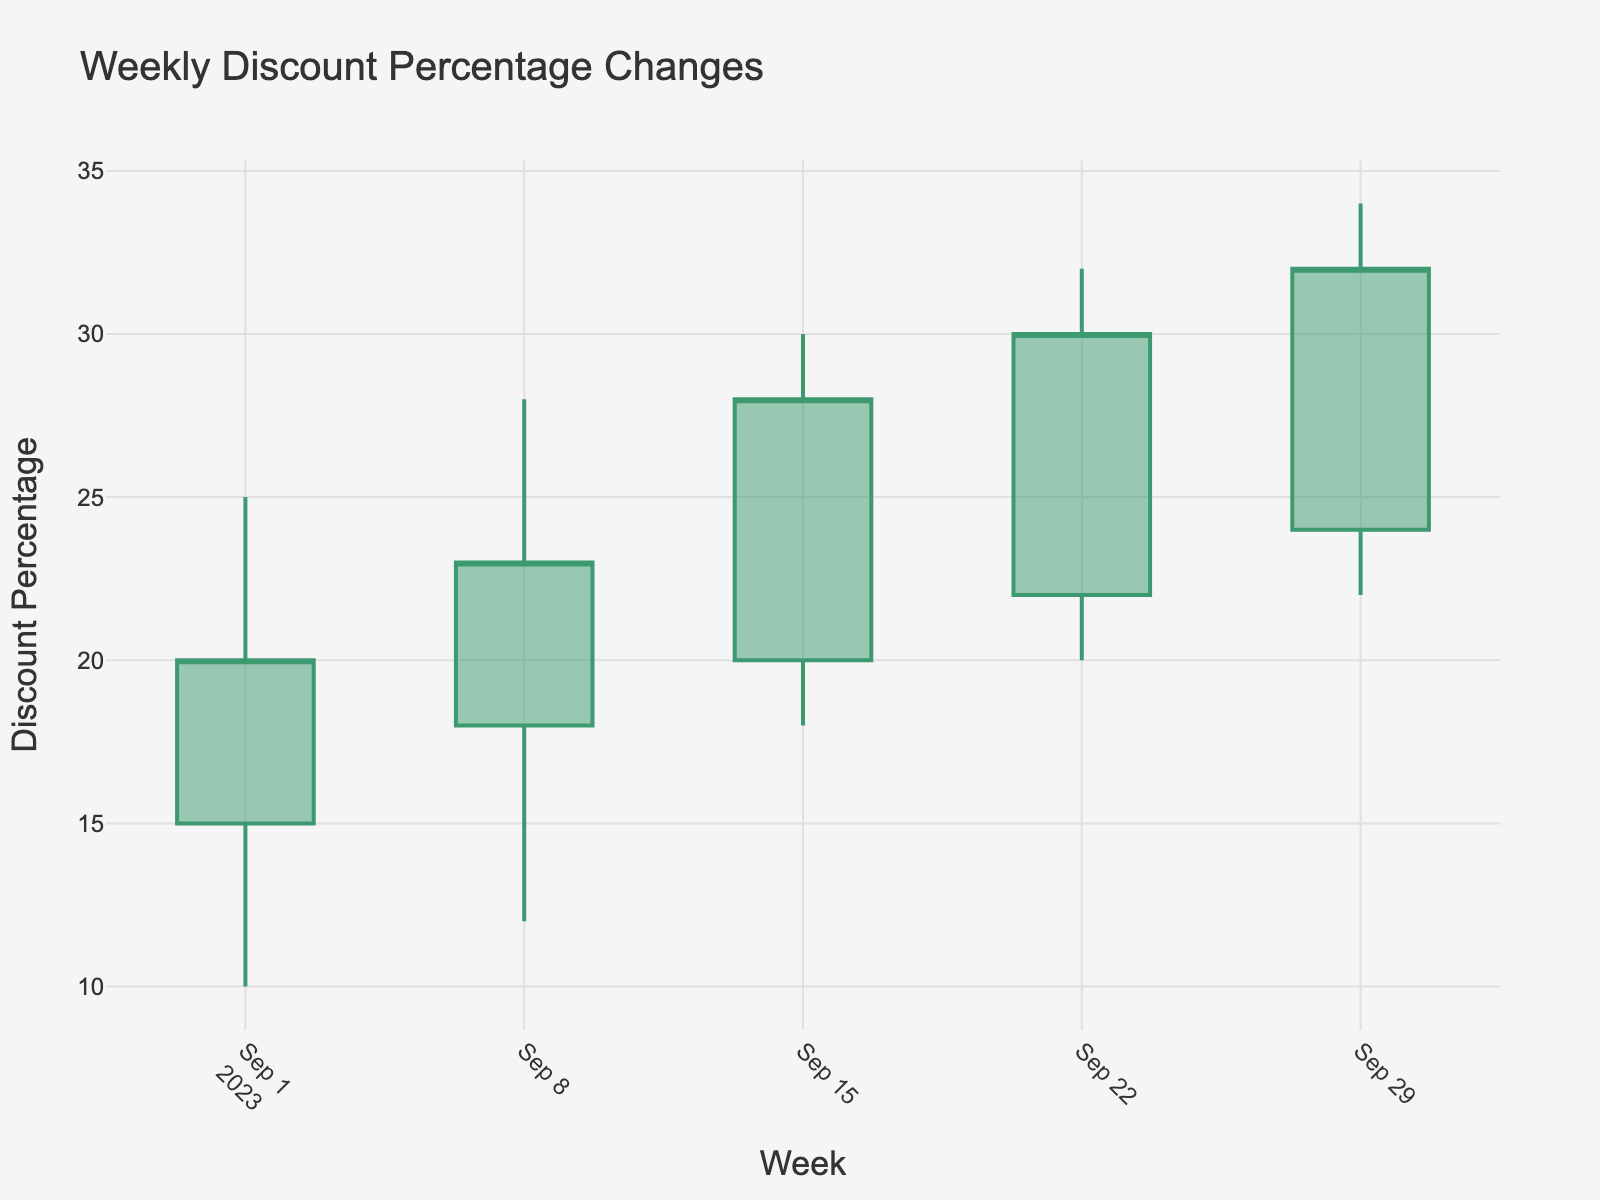What is the title of the plot? The title is located at the top of the plot and provides a summary of what the plot represents.
Answer: Weekly Discount Percentage Changes What does the y-axis represent? The y-axis label is "Discount Percentage," indicating that it represents the percentage discounts.
Answer: Discount Percentage How many weeks are displayed in the plot? The x-axis shows labeled intervals, each corresponding to a different week between September 1, 2023, and September 29, 2023. Counting these intervals gives the number of weeks.
Answer: 5 What are the colors used for increasing and decreasing lines? By looking at the candlestick plot's components, the increasing lines are green, and the decreasing lines are red.
Answer: Green for increasing, Red for decreasing During which week did the highest discount percentage occur? Observing the plot, the highest points of the candlesticks indicate the highest discount percentages. Locate the highest point along the y-axis. This is in the week of 2023-09-29.
Answer: Week of 2023-09-29 What is the general trend in the closing discount percentages over the weeks? The closing values are marked at the end of each candlestick. Observing from the first to last week, we notice if the closing values increase, decrease, or fluctuate.
Answer: Increasing How much did the discount percentage close change from the first to the last week? The closing discount percentage for the first week (2023-09-01) is 20%, and for the last week (2023-09-29), it is 32%. The difference is calculated by 32 - 20.
Answer: 12% Which week had the smallest range of discount percentages, and what was that range? The range of discount percentages for each week can be found by subtracting the low from the high. For the smallest range, compare these ranges for all weeks.
Answer: Week of 2023-09-08, Range: 16% (28% - 12%) How does the opening discount percentage on 2023-09-22 compare to the closing discount percentage on 2023-09-15? Find the opening value on 2023-09-22 and the closing value on 2023-09-15. The opening discount on 2023-09-22 is 22%, and the closing discount on 2023-09-15 is 28%. Compare these values.
Answer: Opening on 2023-09-22 is less than Closing on 2023-09-15 Which week shows the greatest increase in discount percentage from open to close? For each week, subtract the open percentage from the close percentage. The week with the highest positive difference shows the greatest increase. Week of 2023-09-22: 30% - 22% = 8%, which is the greatest increase.
Answer: Week of 2023-09-22 